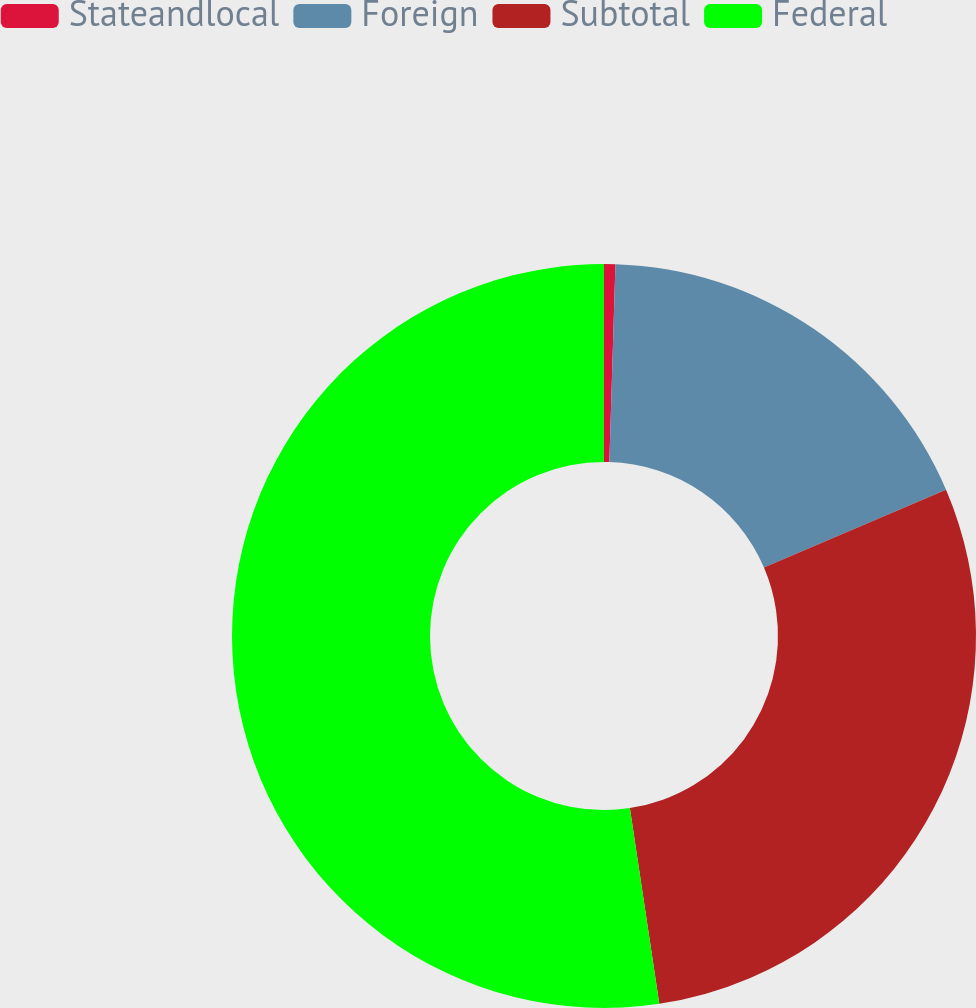<chart> <loc_0><loc_0><loc_500><loc_500><pie_chart><fcel>Stateandlocal<fcel>Foreign<fcel>Subtotal<fcel>Federal<nl><fcel>0.49%<fcel>18.08%<fcel>29.06%<fcel>52.38%<nl></chart> 